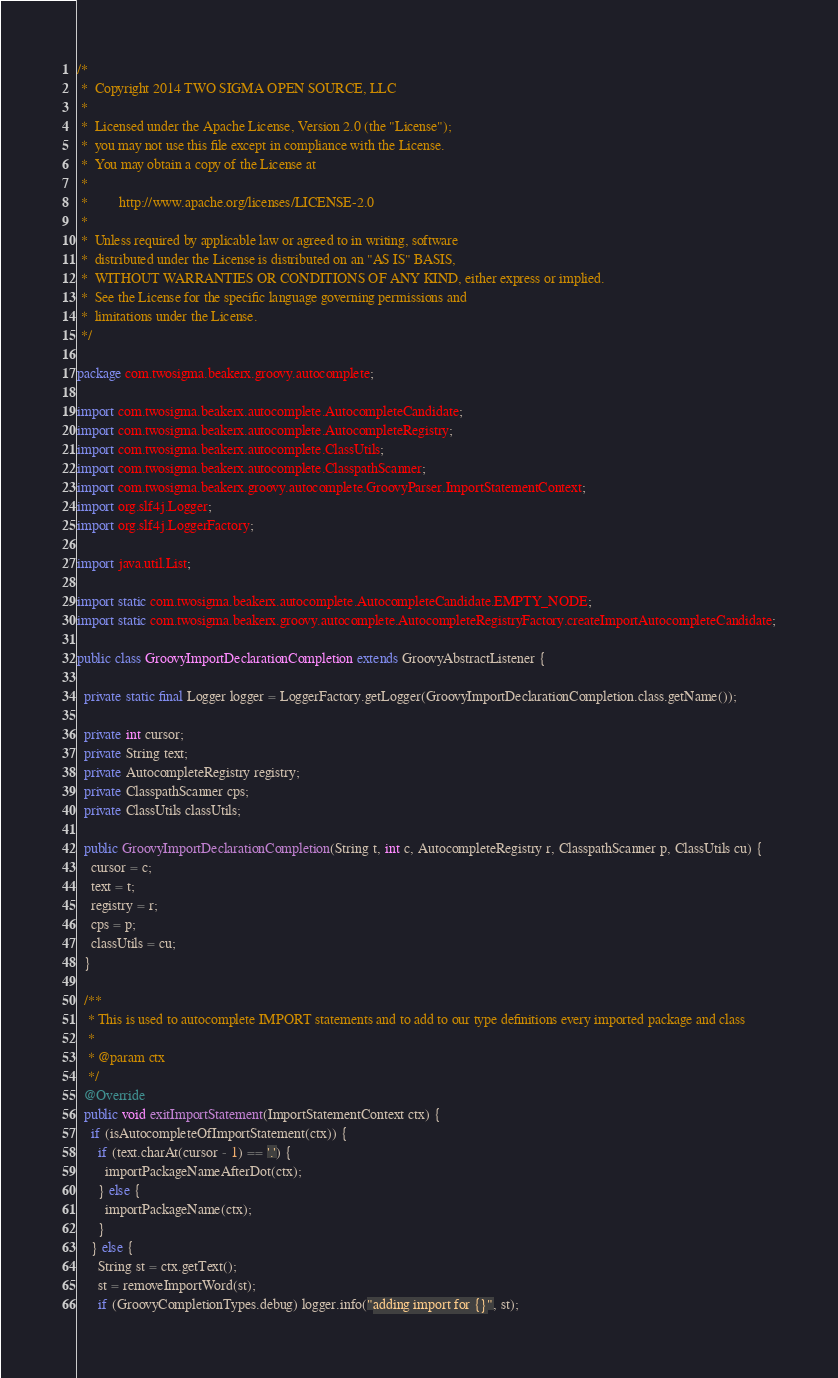Convert code to text. <code><loc_0><loc_0><loc_500><loc_500><_Java_>/*
 *  Copyright 2014 TWO SIGMA OPEN SOURCE, LLC
 *
 *  Licensed under the Apache License, Version 2.0 (the "License");
 *  you may not use this file except in compliance with the License.
 *  You may obtain a copy of the License at
 *
 *         http://www.apache.org/licenses/LICENSE-2.0
 *
 *  Unless required by applicable law or agreed to in writing, software
 *  distributed under the License is distributed on an "AS IS" BASIS,
 *  WITHOUT WARRANTIES OR CONDITIONS OF ANY KIND, either express or implied.
 *  See the License for the specific language governing permissions and
 *  limitations under the License.
 */

package com.twosigma.beakerx.groovy.autocomplete;

import com.twosigma.beakerx.autocomplete.AutocompleteCandidate;
import com.twosigma.beakerx.autocomplete.AutocompleteRegistry;
import com.twosigma.beakerx.autocomplete.ClassUtils;
import com.twosigma.beakerx.autocomplete.ClasspathScanner;
import com.twosigma.beakerx.groovy.autocomplete.GroovyParser.ImportStatementContext;
import org.slf4j.Logger;
import org.slf4j.LoggerFactory;

import java.util.List;

import static com.twosigma.beakerx.autocomplete.AutocompleteCandidate.EMPTY_NODE;
import static com.twosigma.beakerx.groovy.autocomplete.AutocompleteRegistryFactory.createImportAutocompleteCandidate;

public class GroovyImportDeclarationCompletion extends GroovyAbstractListener {

  private static final Logger logger = LoggerFactory.getLogger(GroovyImportDeclarationCompletion.class.getName());

  private int cursor;
  private String text;
  private AutocompleteRegistry registry;
  private ClasspathScanner cps;
  private ClassUtils classUtils;

  public GroovyImportDeclarationCompletion(String t, int c, AutocompleteRegistry r, ClasspathScanner p, ClassUtils cu) {
    cursor = c;
    text = t;
    registry = r;
    cps = p;
    classUtils = cu;
  }

  /**
   * This is used to autocomplete IMPORT statements and to add to our type definitions every imported package and class
   *
   * @param ctx
   */
  @Override
  public void exitImportStatement(ImportStatementContext ctx) {
    if (isAutocompleteOfImportStatement(ctx)) {
      if (text.charAt(cursor - 1) == '.') {
        importPackageNameAfterDot(ctx);
      } else {
        importPackageName(ctx);
      }
    } else {
      String st = ctx.getText();
      st = removeImportWord(st);
      if (GroovyCompletionTypes.debug) logger.info("adding import for {}", st);</code> 